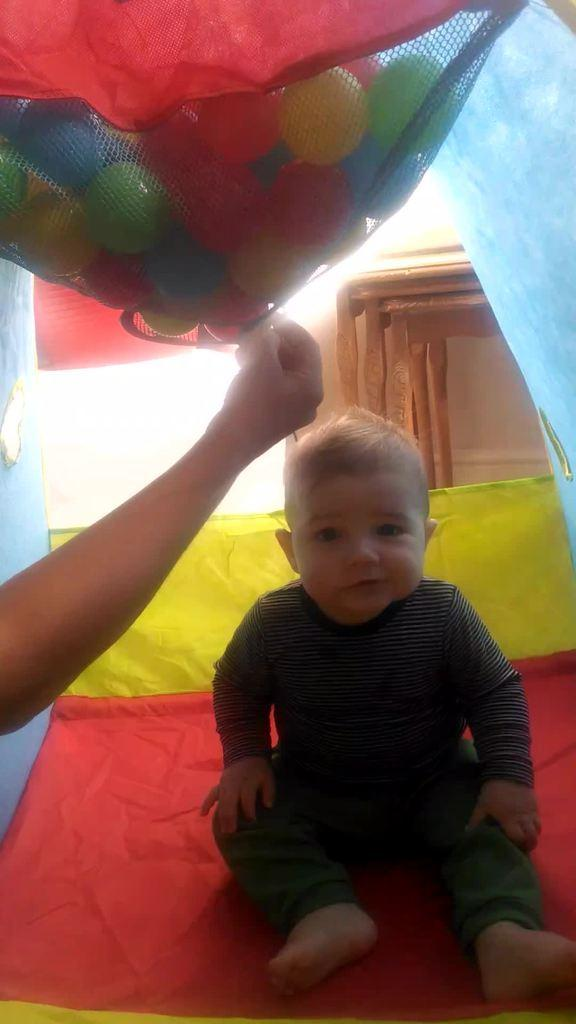What is the kid doing in the image? The kid is sitting on a bed in the image. What can be seen at the top of the image? There are balls visible at the top of the image. Whose hand is visible in the image? There is a hand visible in the image, but it is not specified whose hand it is. What type of advertisement is being displayed on the bed in the image? There is no advertisement present in the image; it features a kid sitting on a bed with balls at the top and a hand visible. How many snakes are slithering on the bed in the image? There are no snakes present in the image; it features a kid sitting on a bed with balls at the top and a hand visible. 